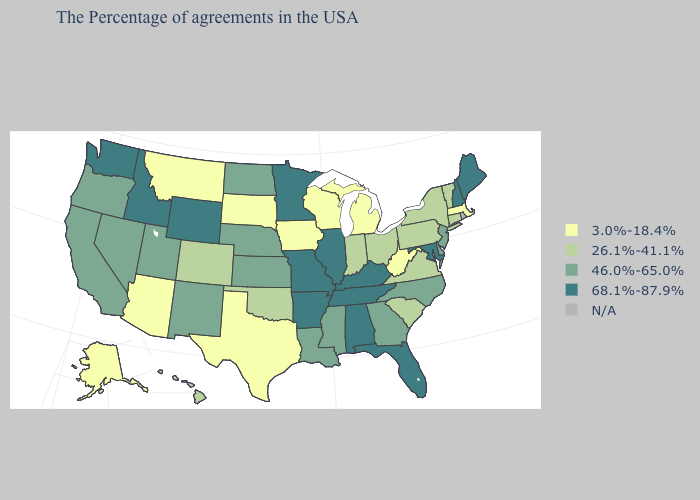What is the lowest value in the USA?
Short answer required. 3.0%-18.4%. Which states have the lowest value in the USA?
Concise answer only. Massachusetts, West Virginia, Michigan, Wisconsin, Iowa, Texas, South Dakota, Montana, Arizona, Alaska. Does West Virginia have the lowest value in the USA?
Keep it brief. Yes. Does Connecticut have the highest value in the USA?
Keep it brief. No. Name the states that have a value in the range 46.0%-65.0%?
Be succinct. New Jersey, Delaware, North Carolina, Georgia, Mississippi, Louisiana, Kansas, Nebraska, North Dakota, New Mexico, Utah, Nevada, California, Oregon. Name the states that have a value in the range N/A?
Write a very short answer. Rhode Island. Among the states that border Vermont , does Massachusetts have the lowest value?
Concise answer only. Yes. What is the value of Indiana?
Keep it brief. 26.1%-41.1%. Name the states that have a value in the range 3.0%-18.4%?
Give a very brief answer. Massachusetts, West Virginia, Michigan, Wisconsin, Iowa, Texas, South Dakota, Montana, Arizona, Alaska. What is the value of Oregon?
Concise answer only. 46.0%-65.0%. Does Florida have the highest value in the USA?
Give a very brief answer. Yes. What is the highest value in states that border Michigan?
Be succinct. 26.1%-41.1%. Which states have the highest value in the USA?
Keep it brief. Maine, New Hampshire, Maryland, Florida, Kentucky, Alabama, Tennessee, Illinois, Missouri, Arkansas, Minnesota, Wyoming, Idaho, Washington. What is the value of Wisconsin?
Quick response, please. 3.0%-18.4%. 